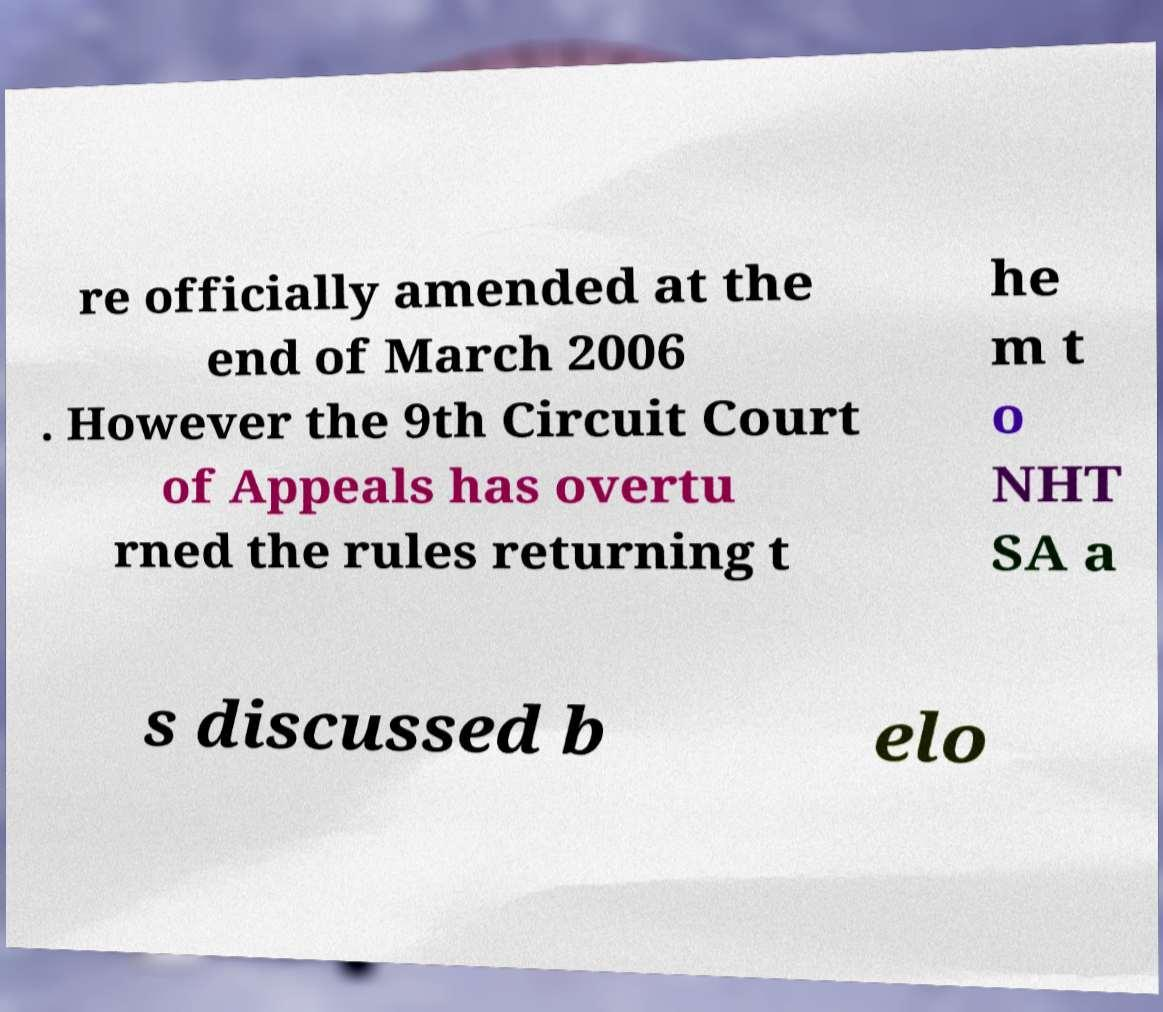Please identify and transcribe the text found in this image. re officially amended at the end of March 2006 . However the 9th Circuit Court of Appeals has overtu rned the rules returning t he m t o NHT SA a s discussed b elo 